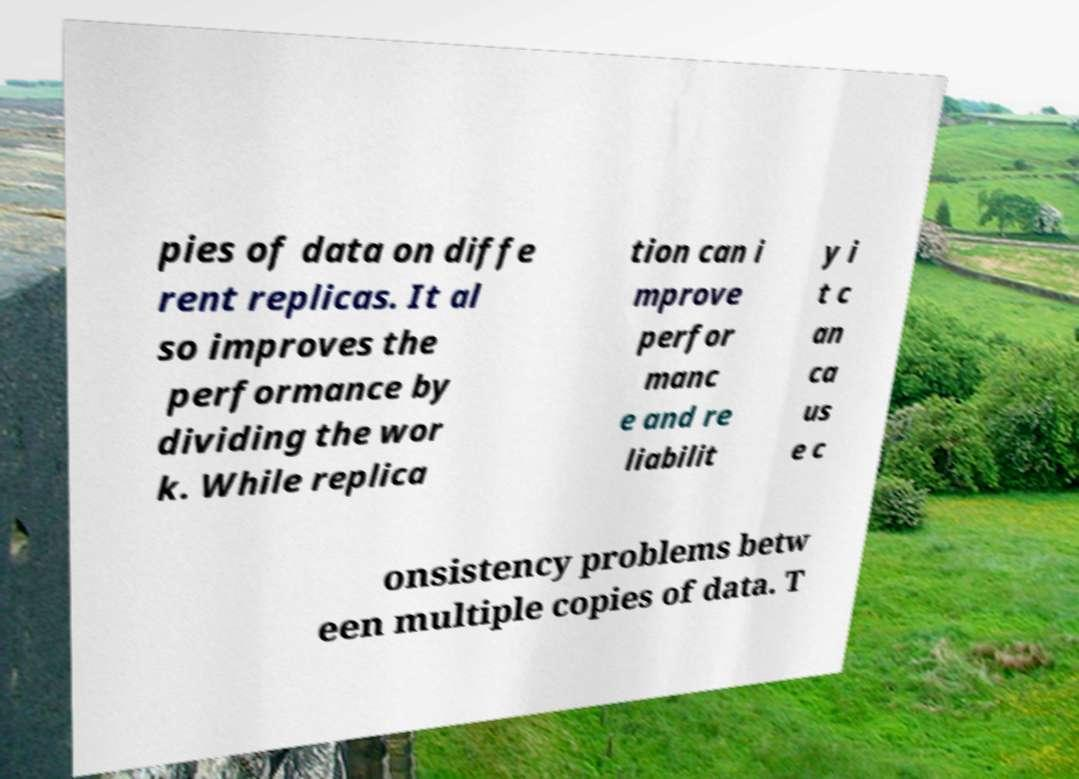What messages or text are displayed in this image? I need them in a readable, typed format. pies of data on diffe rent replicas. It al so improves the performance by dividing the wor k. While replica tion can i mprove perfor manc e and re liabilit y i t c an ca us e c onsistency problems betw een multiple copies of data. T 